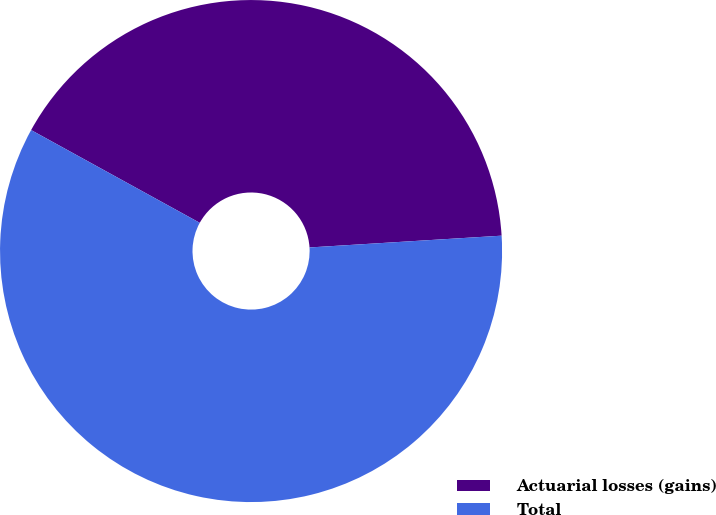Convert chart. <chart><loc_0><loc_0><loc_500><loc_500><pie_chart><fcel>Actuarial losses (gains)<fcel>Total<nl><fcel>41.02%<fcel>58.98%<nl></chart> 